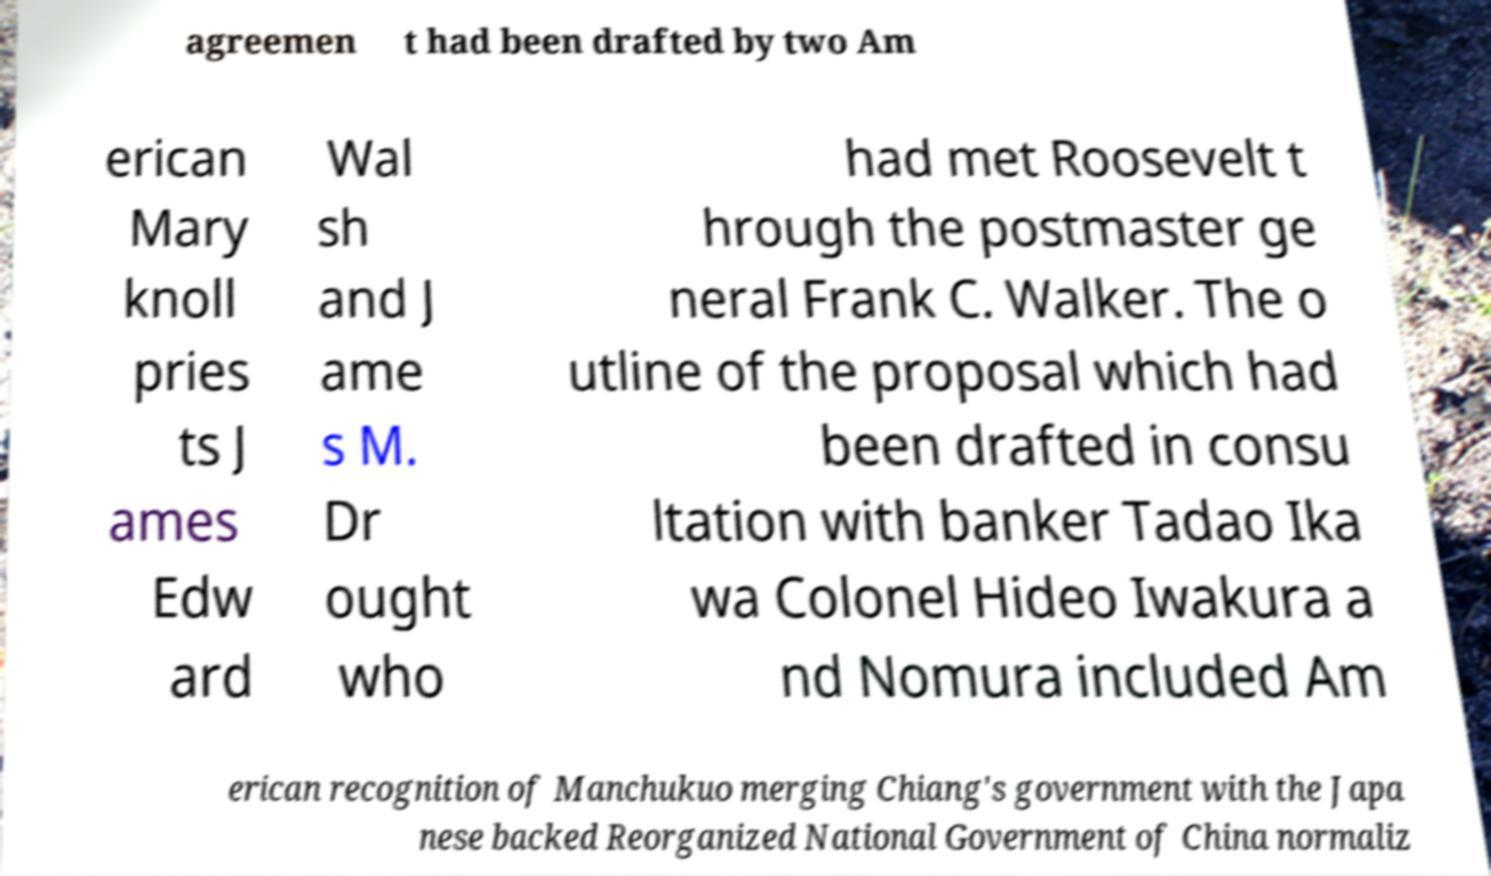Could you extract and type out the text from this image? agreemen t had been drafted by two Am erican Mary knoll pries ts J ames Edw ard Wal sh and J ame s M. Dr ought who had met Roosevelt t hrough the postmaster ge neral Frank C. Walker. The o utline of the proposal which had been drafted in consu ltation with banker Tadao Ika wa Colonel Hideo Iwakura a nd Nomura included Am erican recognition of Manchukuo merging Chiang's government with the Japa nese backed Reorganized National Government of China normaliz 